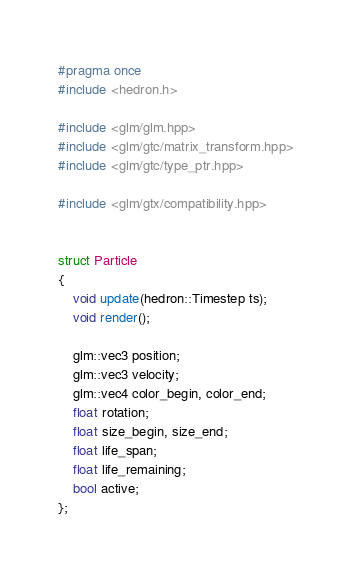Convert code to text. <code><loc_0><loc_0><loc_500><loc_500><_C_>#pragma once
#include <hedron.h>

#include <glm/glm.hpp>
#include <glm/gtc/matrix_transform.hpp>
#include <glm/gtc/type_ptr.hpp>

#include <glm/gtx/compatibility.hpp>


struct Particle
{
	void update(hedron::Timestep ts);
	void render();
	
	glm::vec3 position;
	glm::vec3 velocity;
	glm::vec4 color_begin, color_end;
	float rotation;
	float size_begin, size_end;
	float life_span;
	float life_remaining;
	bool active;
};</code> 